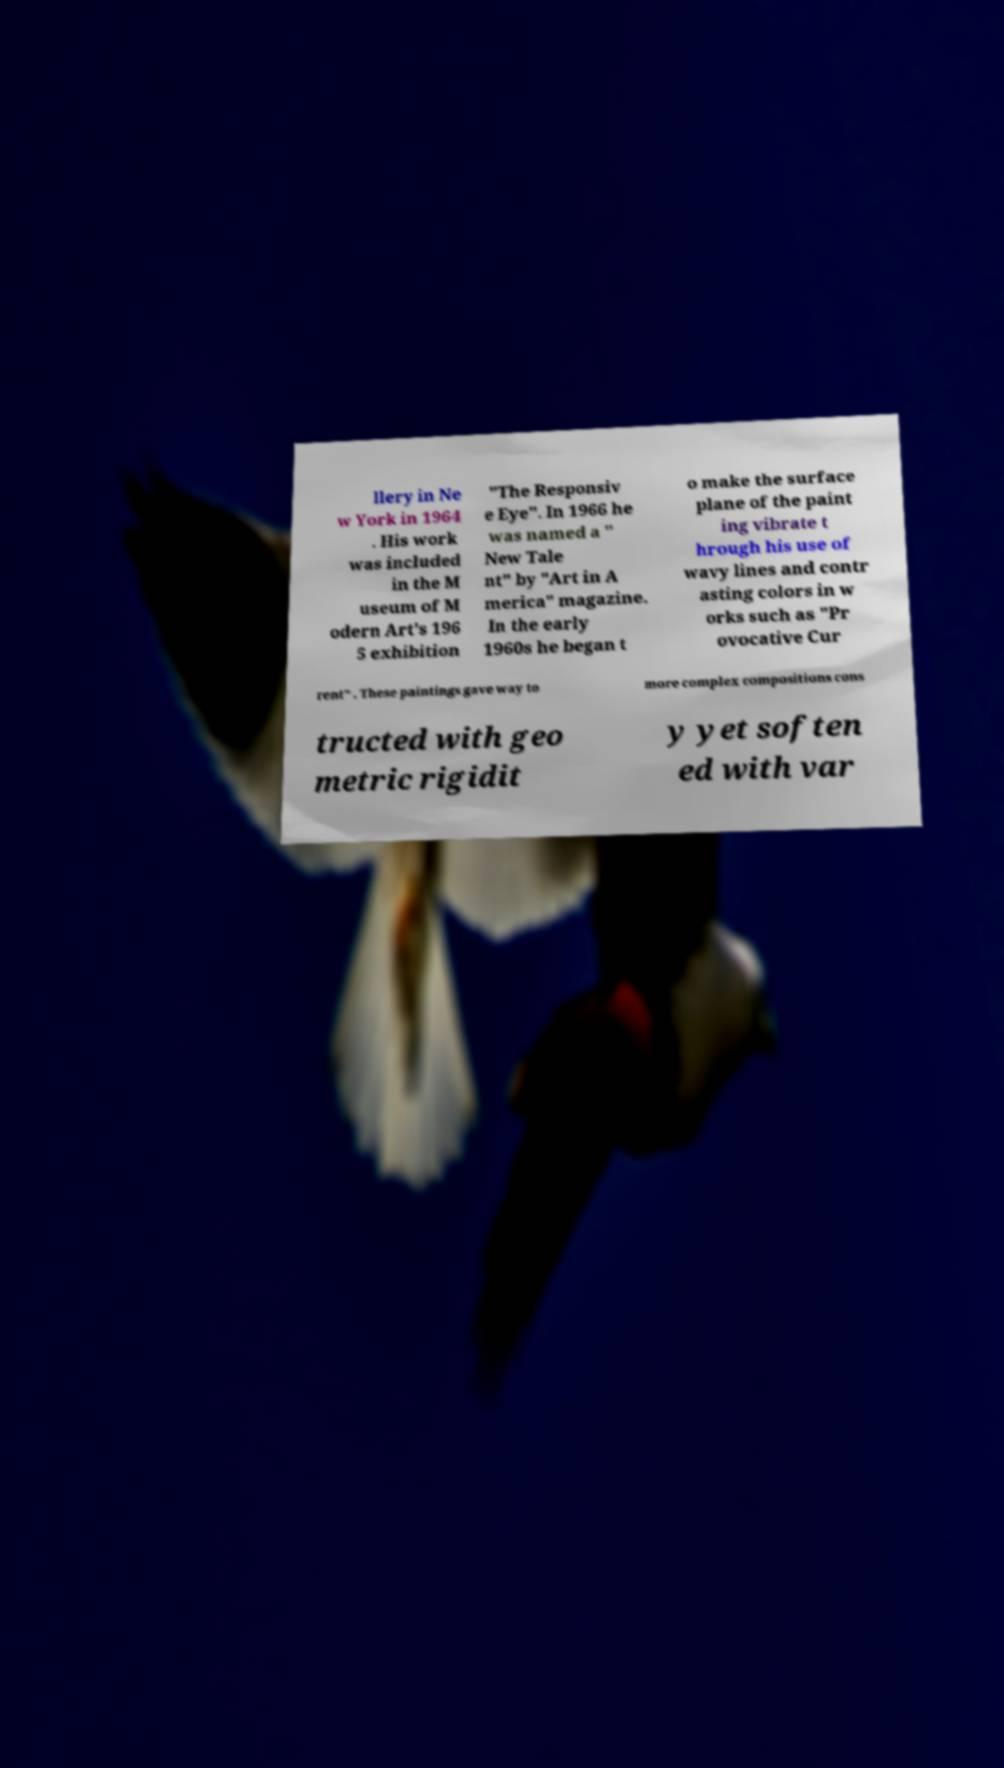There's text embedded in this image that I need extracted. Can you transcribe it verbatim? llery in Ne w York in 1964 . His work was included in the M useum of M odern Art's 196 5 exhibition "The Responsiv e Eye". In 1966 he was named a " New Tale nt" by "Art in A merica" magazine. In the early 1960s he began t o make the surface plane of the paint ing vibrate t hrough his use of wavy lines and contr asting colors in w orks such as "Pr ovocative Cur rent" . These paintings gave way to more complex compositions cons tructed with geo metric rigidit y yet soften ed with var 